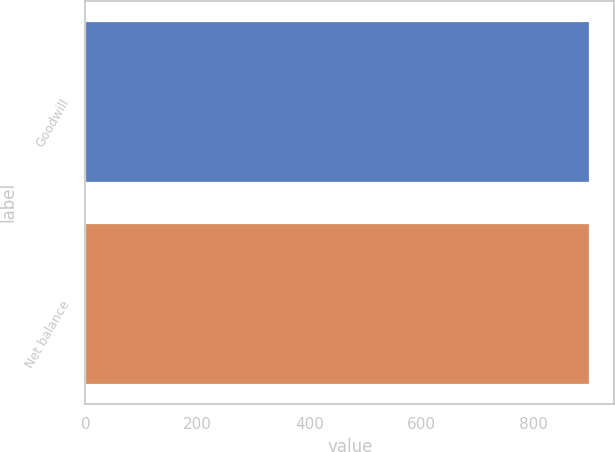Convert chart to OTSL. <chart><loc_0><loc_0><loc_500><loc_500><bar_chart><fcel>Goodwill<fcel>Net balance<nl><fcel>899<fcel>899.1<nl></chart> 